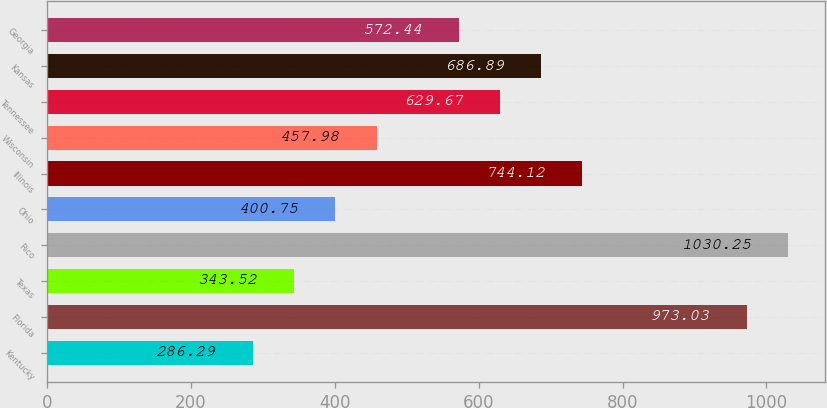Convert chart. <chart><loc_0><loc_0><loc_500><loc_500><bar_chart><fcel>Kentucky<fcel>Florida<fcel>Texas<fcel>Rico<fcel>Ohio<fcel>Illinois<fcel>Wisconsin<fcel>Tennessee<fcel>Kansas<fcel>Georgia<nl><fcel>286.29<fcel>973.03<fcel>343.52<fcel>1030.25<fcel>400.75<fcel>744.12<fcel>457.98<fcel>629.67<fcel>686.89<fcel>572.44<nl></chart> 